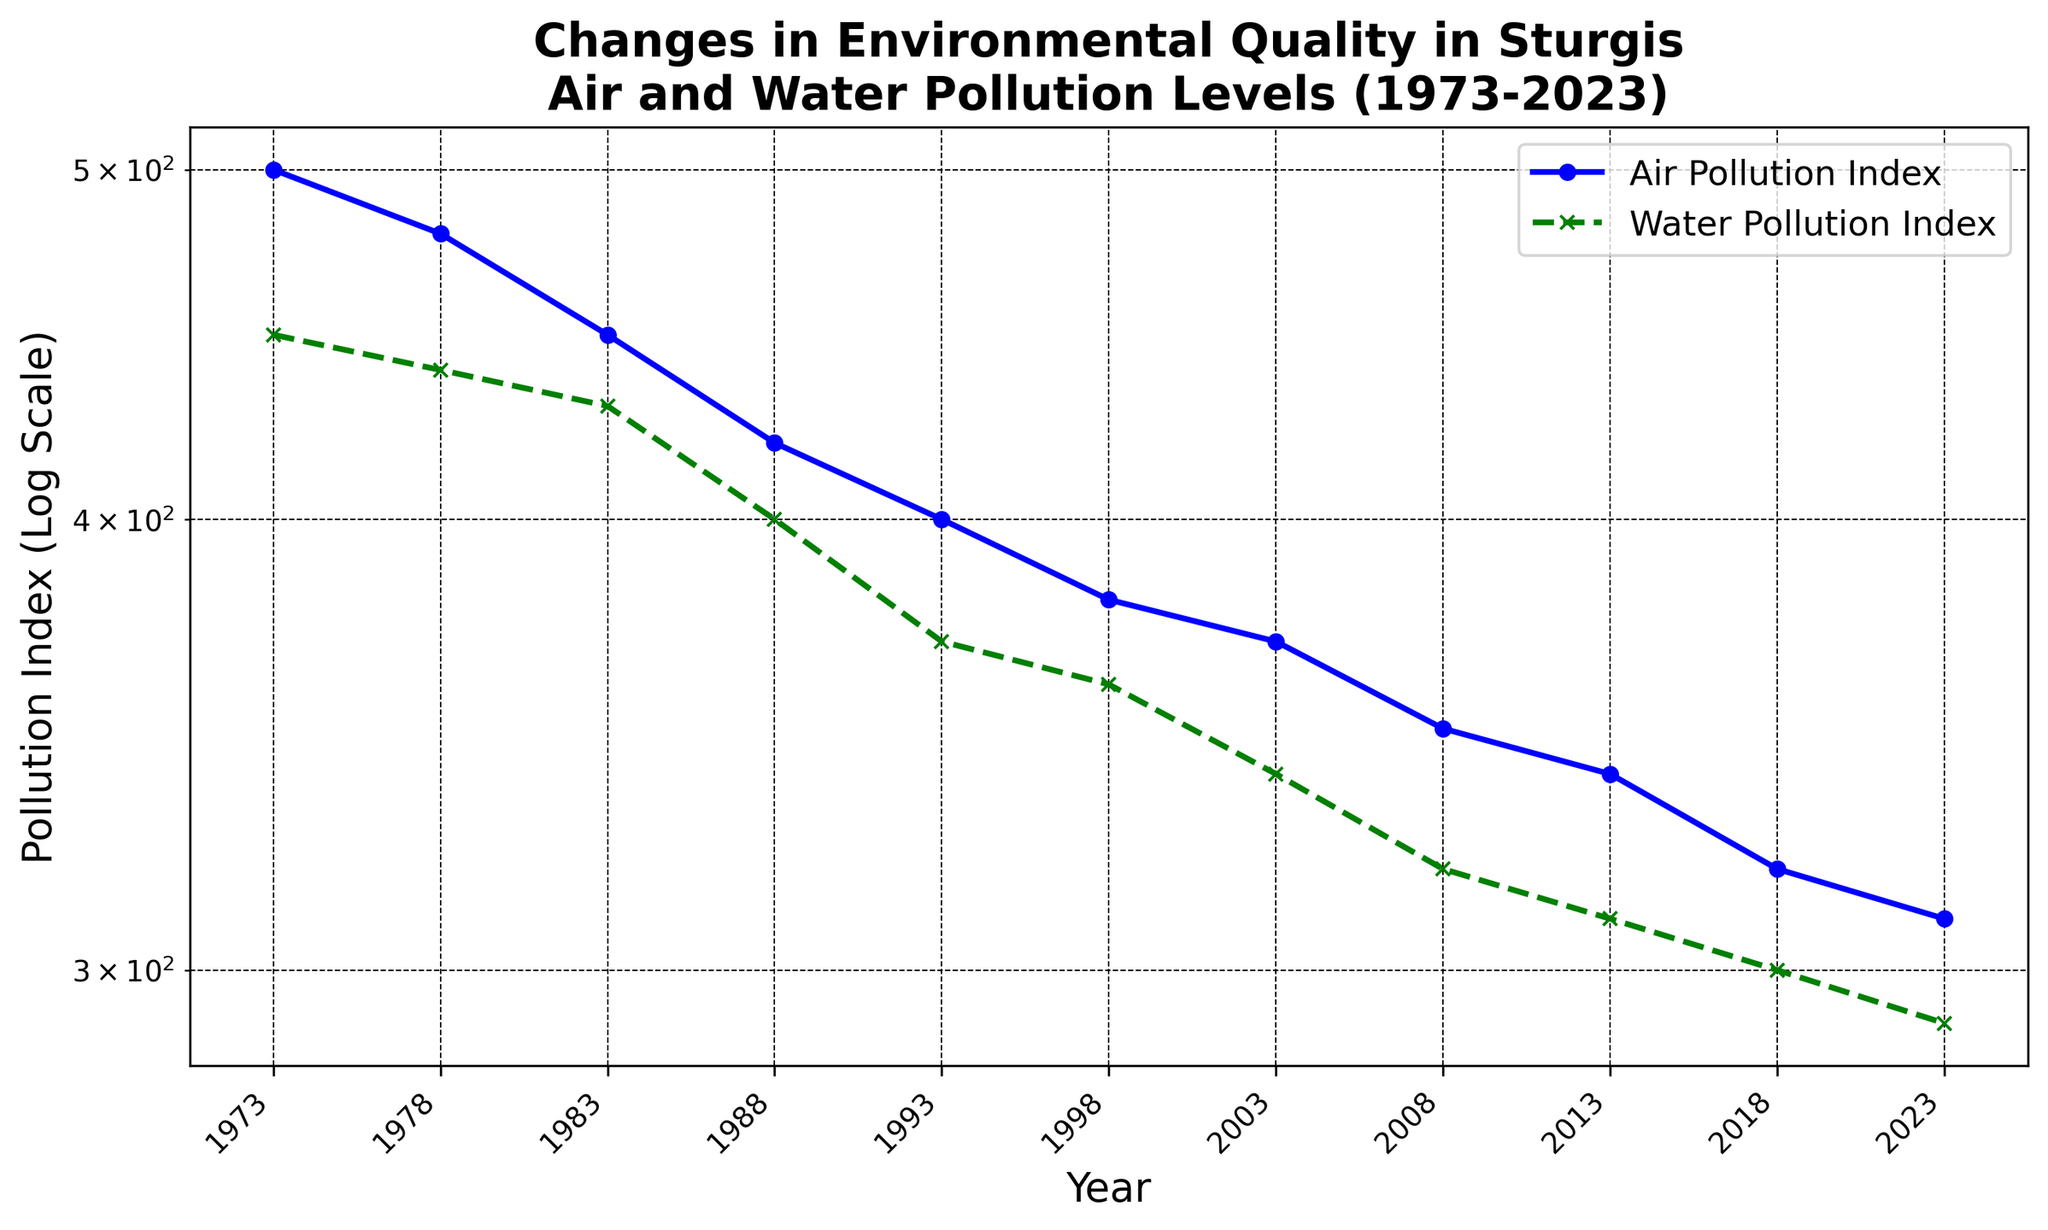What is the overall trend of both air and water pollution levels over the 50-year period? Both the air and water pollution indices show a clear downward trend from 1973 to 2023, indicating an improvement in environmental quality. The indices decrease steadily over the years.
Answer: Downward trend Which year shows the greatest reduction in both air and water pollution indices compared to the previous recorded year? By looking at the year-over-year changes, the largest reduction in air pollution occurs from 1973 to 1978 (500 to 480), and the largest reduction in water pollution also occurs from 1973 to 1978 (450 to 440). Therefore, the year 1978 shows the greatest reduction in both indices compared to the previous recorded year.
Answer: 1978 What is the difference between the air pollution index and water pollution index in the year 2023? The air pollution index in 2023 is 310, and the water pollution index is 290. The difference between the two indices is 310 - 290 = 20.
Answer: 20 During which decade did Sturgis see the smallest decrease in air pollution indices? To find the decade with the smallest decrease, compare the air pollution indices at the start and end of each decade: 
1973-1983: 500 - 450 = 50
1983-1993: 450 - 400 = 50
1993-2003: 400 - 370 = 30
2003-2013: 370 - 340 = 30
2013-2023: 340 - 310 = 30
The smallest decrease is seen from 1993-2003, from 2003-2013, and from 2013-2023, all tied at a decrease of 30 points.
Answer: 1993-2003, 2003-2013, 2013-2023 Which pollutant index was consistently higher until the year 2023? From the plotted data, the air pollution index is consistently higher than the water pollution index from 1973 to 2023.
Answer: Air pollution How does the air pollution index in 1993 compare to the water pollution index in 1998? In the year 1993, the air pollution index is 400, and the water pollution index in 1998 is 360. The air pollution index in 1993 is higher than the water pollution index in 1998.
Answer: Air pollution index in 1993 is higher By what percentage did the water pollution index decrease from 1973 to 2023? The water pollution index in 1973 was 450, and in 2023, it was 290. The decrease percentage is calculated as [(450 - 290) / 450] * 100 = 35.56%.
Answer: 35.56% What are the colors of the lines representing air and water pollution indices in the figure? The air pollution index is represented by a blue line, and the water pollution index is represented by a green line.
Answer: Blue for air pollution, green for water pollution 